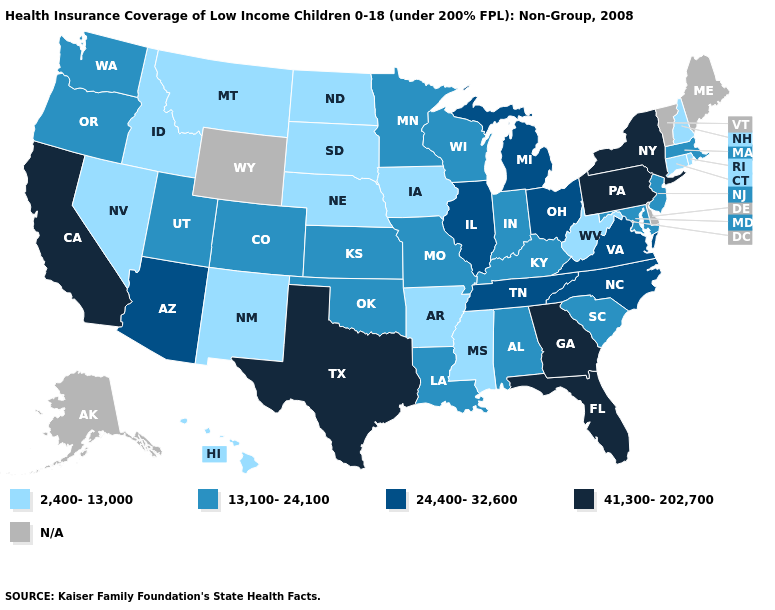What is the value of Mississippi?
Write a very short answer. 2,400-13,000. What is the lowest value in states that border North Dakota?
Quick response, please. 2,400-13,000. What is the highest value in the South ?
Be succinct. 41,300-202,700. What is the lowest value in states that border Louisiana?
Write a very short answer. 2,400-13,000. What is the value of Maine?
Quick response, please. N/A. Name the states that have a value in the range N/A?
Concise answer only. Alaska, Delaware, Maine, Vermont, Wyoming. What is the value of Alabama?
Give a very brief answer. 13,100-24,100. What is the highest value in the USA?
Keep it brief. 41,300-202,700. What is the value of Michigan?
Concise answer only. 24,400-32,600. Name the states that have a value in the range 41,300-202,700?
Quick response, please. California, Florida, Georgia, New York, Pennsylvania, Texas. Does Iowa have the lowest value in the MidWest?
Quick response, please. Yes. Name the states that have a value in the range 13,100-24,100?
Short answer required. Alabama, Colorado, Indiana, Kansas, Kentucky, Louisiana, Maryland, Massachusetts, Minnesota, Missouri, New Jersey, Oklahoma, Oregon, South Carolina, Utah, Washington, Wisconsin. What is the value of Iowa?
Answer briefly. 2,400-13,000. What is the value of Nevada?
Answer briefly. 2,400-13,000. 